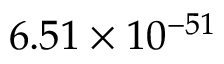<formula> <loc_0><loc_0><loc_500><loc_500>6 . 5 1 \times 1 0 ^ { - 5 1 }</formula> 